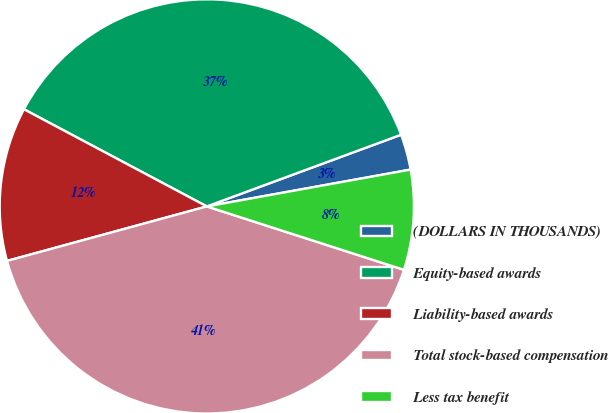<chart> <loc_0><loc_0><loc_500><loc_500><pie_chart><fcel>(DOLLARS IN THOUSANDS)<fcel>Equity-based awards<fcel>Liability-based awards<fcel>Total stock-based compensation<fcel>Less tax benefit<nl><fcel>2.78%<fcel>36.6%<fcel>12.01%<fcel>40.81%<fcel>7.8%<nl></chart> 